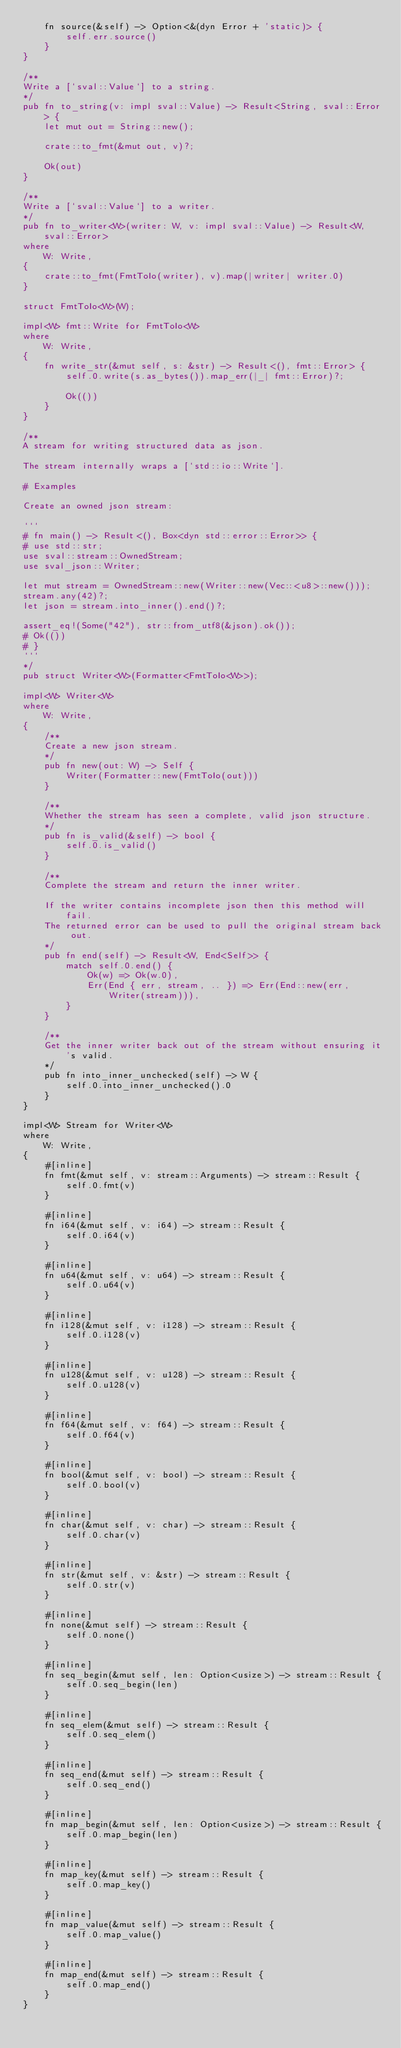<code> <loc_0><loc_0><loc_500><loc_500><_Rust_>    fn source(&self) -> Option<&(dyn Error + 'static)> {
        self.err.source()
    }
}

/**
Write a [`sval::Value`] to a string.
*/
pub fn to_string(v: impl sval::Value) -> Result<String, sval::Error> {
    let mut out = String::new();

    crate::to_fmt(&mut out, v)?;

    Ok(out)
}

/**
Write a [`sval::Value`] to a writer.
*/
pub fn to_writer<W>(writer: W, v: impl sval::Value) -> Result<W, sval::Error>
where
    W: Write,
{
    crate::to_fmt(FmtToIo(writer), v).map(|writer| writer.0)
}

struct FmtToIo<W>(W);

impl<W> fmt::Write for FmtToIo<W>
where
    W: Write,
{
    fn write_str(&mut self, s: &str) -> Result<(), fmt::Error> {
        self.0.write(s.as_bytes()).map_err(|_| fmt::Error)?;

        Ok(())
    }
}

/**
A stream for writing structured data as json.

The stream internally wraps a [`std::io::Write`].

# Examples

Create an owned json stream:

```
# fn main() -> Result<(), Box<dyn std::error::Error>> {
# use std::str;
use sval::stream::OwnedStream;
use sval_json::Writer;

let mut stream = OwnedStream::new(Writer::new(Vec::<u8>::new()));
stream.any(42)?;
let json = stream.into_inner().end()?;

assert_eq!(Some("42"), str::from_utf8(&json).ok());
# Ok(())
# }
```
*/
pub struct Writer<W>(Formatter<FmtToIo<W>>);

impl<W> Writer<W>
where
    W: Write,
{
    /**
    Create a new json stream.
    */
    pub fn new(out: W) -> Self {
        Writer(Formatter::new(FmtToIo(out)))
    }

    /**
    Whether the stream has seen a complete, valid json structure.
    */
    pub fn is_valid(&self) -> bool {
        self.0.is_valid()
    }

    /**
    Complete the stream and return the inner writer.

    If the writer contains incomplete json then this method will fail.
    The returned error can be used to pull the original stream back out.
    */
    pub fn end(self) -> Result<W, End<Self>> {
        match self.0.end() {
            Ok(w) => Ok(w.0),
            Err(End { err, stream, .. }) => Err(End::new(err, Writer(stream))),
        }
    }

    /**
    Get the inner writer back out of the stream without ensuring it's valid.
    */
    pub fn into_inner_unchecked(self) -> W {
        self.0.into_inner_unchecked().0
    }
}

impl<W> Stream for Writer<W>
where
    W: Write,
{
    #[inline]
    fn fmt(&mut self, v: stream::Arguments) -> stream::Result {
        self.0.fmt(v)
    }

    #[inline]
    fn i64(&mut self, v: i64) -> stream::Result {
        self.0.i64(v)
    }

    #[inline]
    fn u64(&mut self, v: u64) -> stream::Result {
        self.0.u64(v)
    }

    #[inline]
    fn i128(&mut self, v: i128) -> stream::Result {
        self.0.i128(v)
    }

    #[inline]
    fn u128(&mut self, v: u128) -> stream::Result {
        self.0.u128(v)
    }

    #[inline]
    fn f64(&mut self, v: f64) -> stream::Result {
        self.0.f64(v)
    }

    #[inline]
    fn bool(&mut self, v: bool) -> stream::Result {
        self.0.bool(v)
    }

    #[inline]
    fn char(&mut self, v: char) -> stream::Result {
        self.0.char(v)
    }

    #[inline]
    fn str(&mut self, v: &str) -> stream::Result {
        self.0.str(v)
    }

    #[inline]
    fn none(&mut self) -> stream::Result {
        self.0.none()
    }

    #[inline]
    fn seq_begin(&mut self, len: Option<usize>) -> stream::Result {
        self.0.seq_begin(len)
    }

    #[inline]
    fn seq_elem(&mut self) -> stream::Result {
        self.0.seq_elem()
    }

    #[inline]
    fn seq_end(&mut self) -> stream::Result {
        self.0.seq_end()
    }

    #[inline]
    fn map_begin(&mut self, len: Option<usize>) -> stream::Result {
        self.0.map_begin(len)
    }

    #[inline]
    fn map_key(&mut self) -> stream::Result {
        self.0.map_key()
    }

    #[inline]
    fn map_value(&mut self) -> stream::Result {
        self.0.map_value()
    }

    #[inline]
    fn map_end(&mut self) -> stream::Result {
        self.0.map_end()
    }
}
</code> 